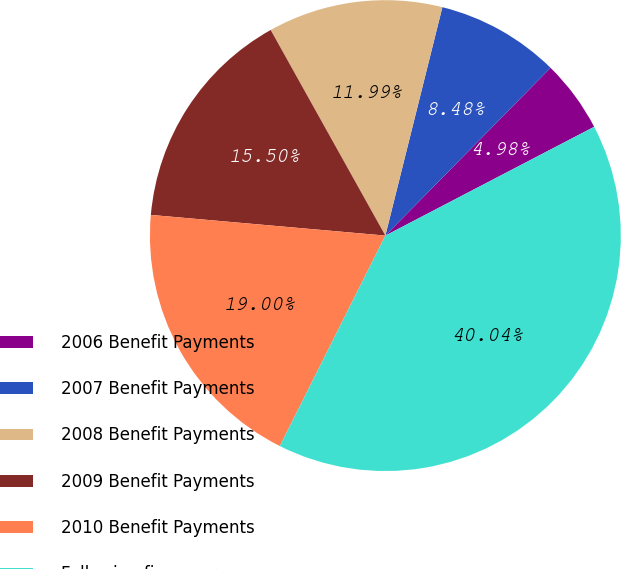Convert chart. <chart><loc_0><loc_0><loc_500><loc_500><pie_chart><fcel>2006 Benefit Payments<fcel>2007 Benefit Payments<fcel>2008 Benefit Payments<fcel>2009 Benefit Payments<fcel>2010 Benefit Payments<fcel>Following five years<nl><fcel>4.98%<fcel>8.48%<fcel>11.99%<fcel>15.5%<fcel>19.0%<fcel>40.04%<nl></chart> 